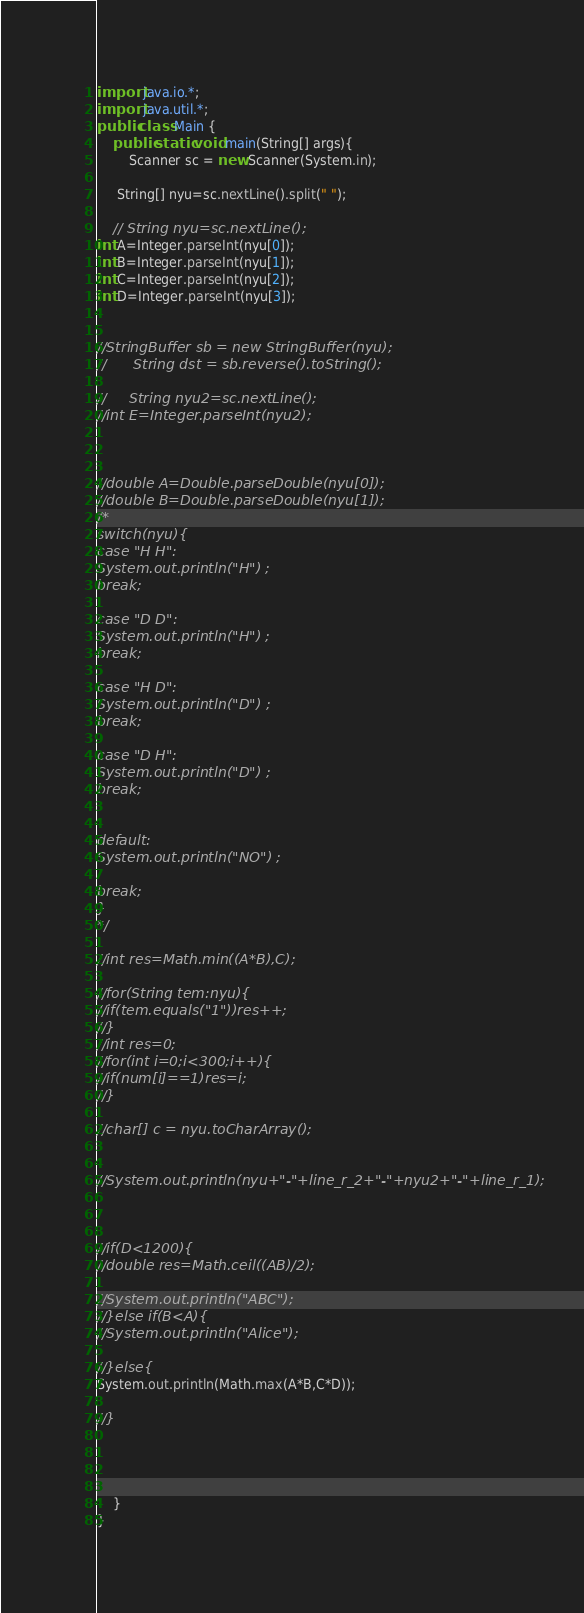<code> <loc_0><loc_0><loc_500><loc_500><_Java_>import java.io.*;
import java.util.*;
public class Main {
	public static void main(String[] args){
		Scanner sc = new Scanner(System.in);
 
     String[] nyu=sc.nextLine().split(" ");

    // String nyu=sc.nextLine();
int A=Integer.parseInt(nyu[0]);
int B=Integer.parseInt(nyu[1]);
int C=Integer.parseInt(nyu[2]);
int D=Integer.parseInt(nyu[3]);


//StringBuffer sb = new StringBuffer(nyu);
//		String dst = sb.reverse().toString();

//     String nyu2=sc.nextLine();
//int E=Integer.parseInt(nyu2);



//double A=Double.parseDouble(nyu[0]);
//double B=Double.parseDouble(nyu[1]);
/*
switch(nyu){
case "H H":
System.out.println("H") ;
break;

case "D D":
System.out.println("H") ;
break;

case "H D":
System.out.println("D") ;
break;

case "D H":
System.out.println("D") ;
break;


default:
System.out.println("NO") ;

break;
}
*/

//int res=Math.min((A*B),C);

//for(String tem:nyu){
//if(tem.equals("1"))res++;
//}
//int res=0;
//for(int i=0;i<300;i++){
//if(num[i]==1)res=i;
//}

//char[] c = nyu.toCharArray();


//System.out.println(nyu+"-"+line_r_2+"-"+nyu2+"-"+line_r_1);



//if(D<1200){
//double res=Math.ceil((AB)/2);

//System.out.println("ABC");
//}else if(B<A){
//System.out.println("Alice");

//}else{
System.out.println(Math.max(A*B,C*D));

//}




	}
}</code> 